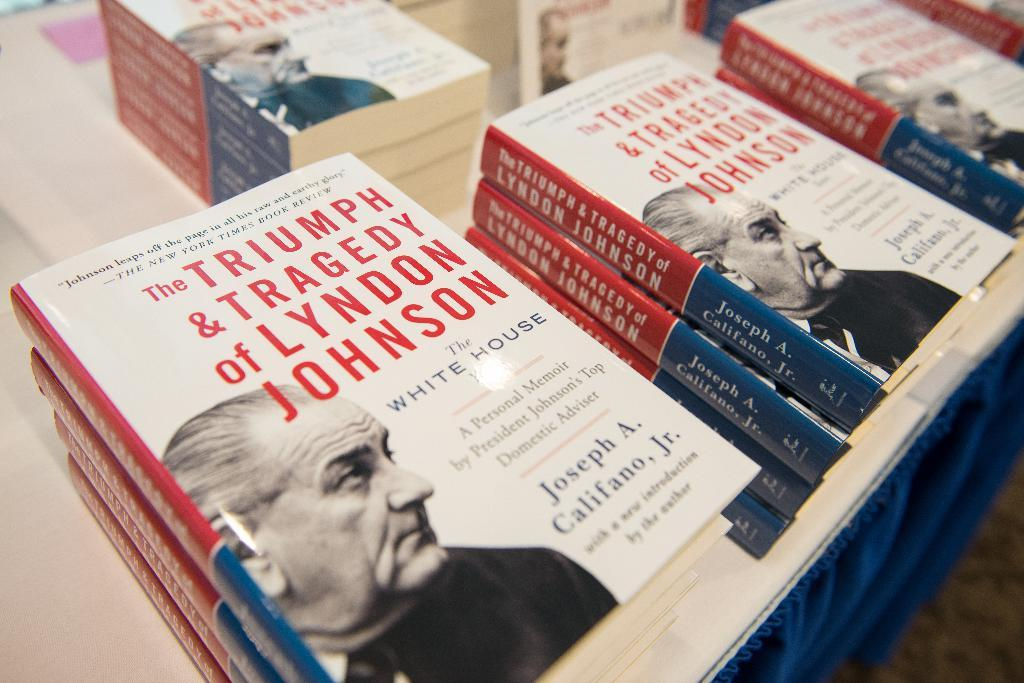<image>
Create a compact narrative representing the image presented. The book titled The Triumph & Tragedy of Lyndon Johnson is displayed in hardcover and softcover versions. 